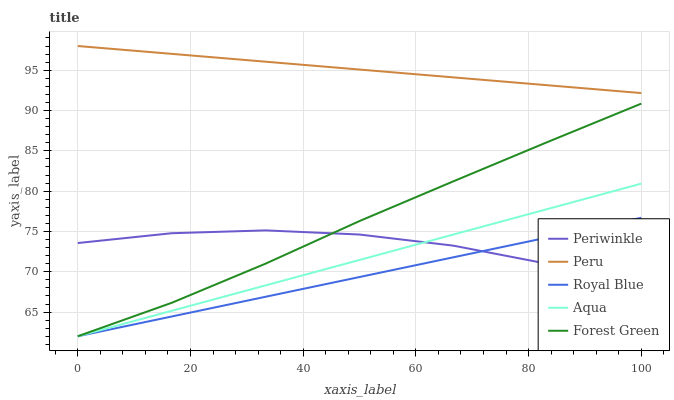Does Royal Blue have the minimum area under the curve?
Answer yes or no. Yes. Does Peru have the maximum area under the curve?
Answer yes or no. Yes. Does Forest Green have the minimum area under the curve?
Answer yes or no. No. Does Forest Green have the maximum area under the curve?
Answer yes or no. No. Is Royal Blue the smoothest?
Answer yes or no. Yes. Is Periwinkle the roughest?
Answer yes or no. Yes. Is Forest Green the smoothest?
Answer yes or no. No. Is Forest Green the roughest?
Answer yes or no. No. Does Aqua have the lowest value?
Answer yes or no. Yes. Does Periwinkle have the lowest value?
Answer yes or no. No. Does Peru have the highest value?
Answer yes or no. Yes. Does Royal Blue have the highest value?
Answer yes or no. No. Is Forest Green less than Peru?
Answer yes or no. Yes. Is Peru greater than Periwinkle?
Answer yes or no. Yes. Does Forest Green intersect Royal Blue?
Answer yes or no. Yes. Is Forest Green less than Royal Blue?
Answer yes or no. No. Is Forest Green greater than Royal Blue?
Answer yes or no. No. Does Forest Green intersect Peru?
Answer yes or no. No. 